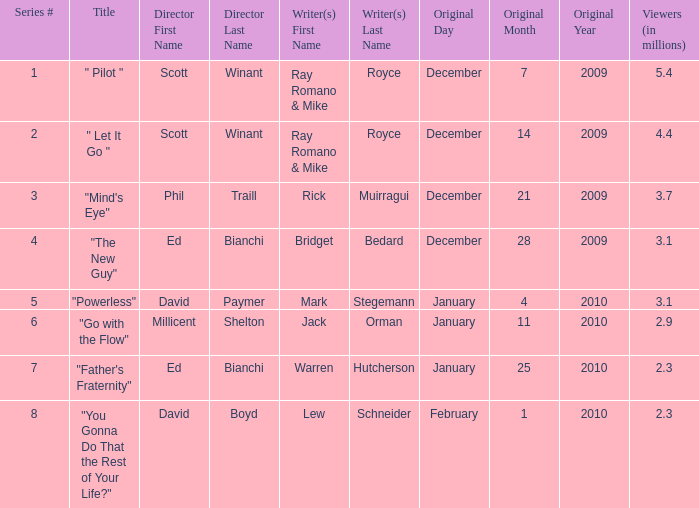How many viewers (in millions) did episode 1 have? 5.4. 